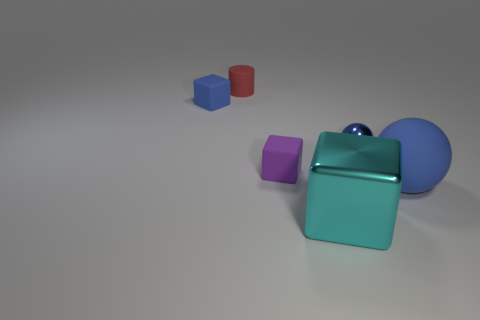Subtract all blue blocks. How many blocks are left? 2 Subtract all cylinders. How many objects are left? 5 Add 4 large cyan spheres. How many objects exist? 10 Subtract all big gray balls. Subtract all spheres. How many objects are left? 4 Add 4 matte blocks. How many matte blocks are left? 6 Add 1 small spheres. How many small spheres exist? 2 Subtract 0 yellow cylinders. How many objects are left? 6 Subtract 1 cylinders. How many cylinders are left? 0 Subtract all green blocks. Subtract all yellow balls. How many blocks are left? 3 Subtract all blue cubes. How many blue cylinders are left? 0 